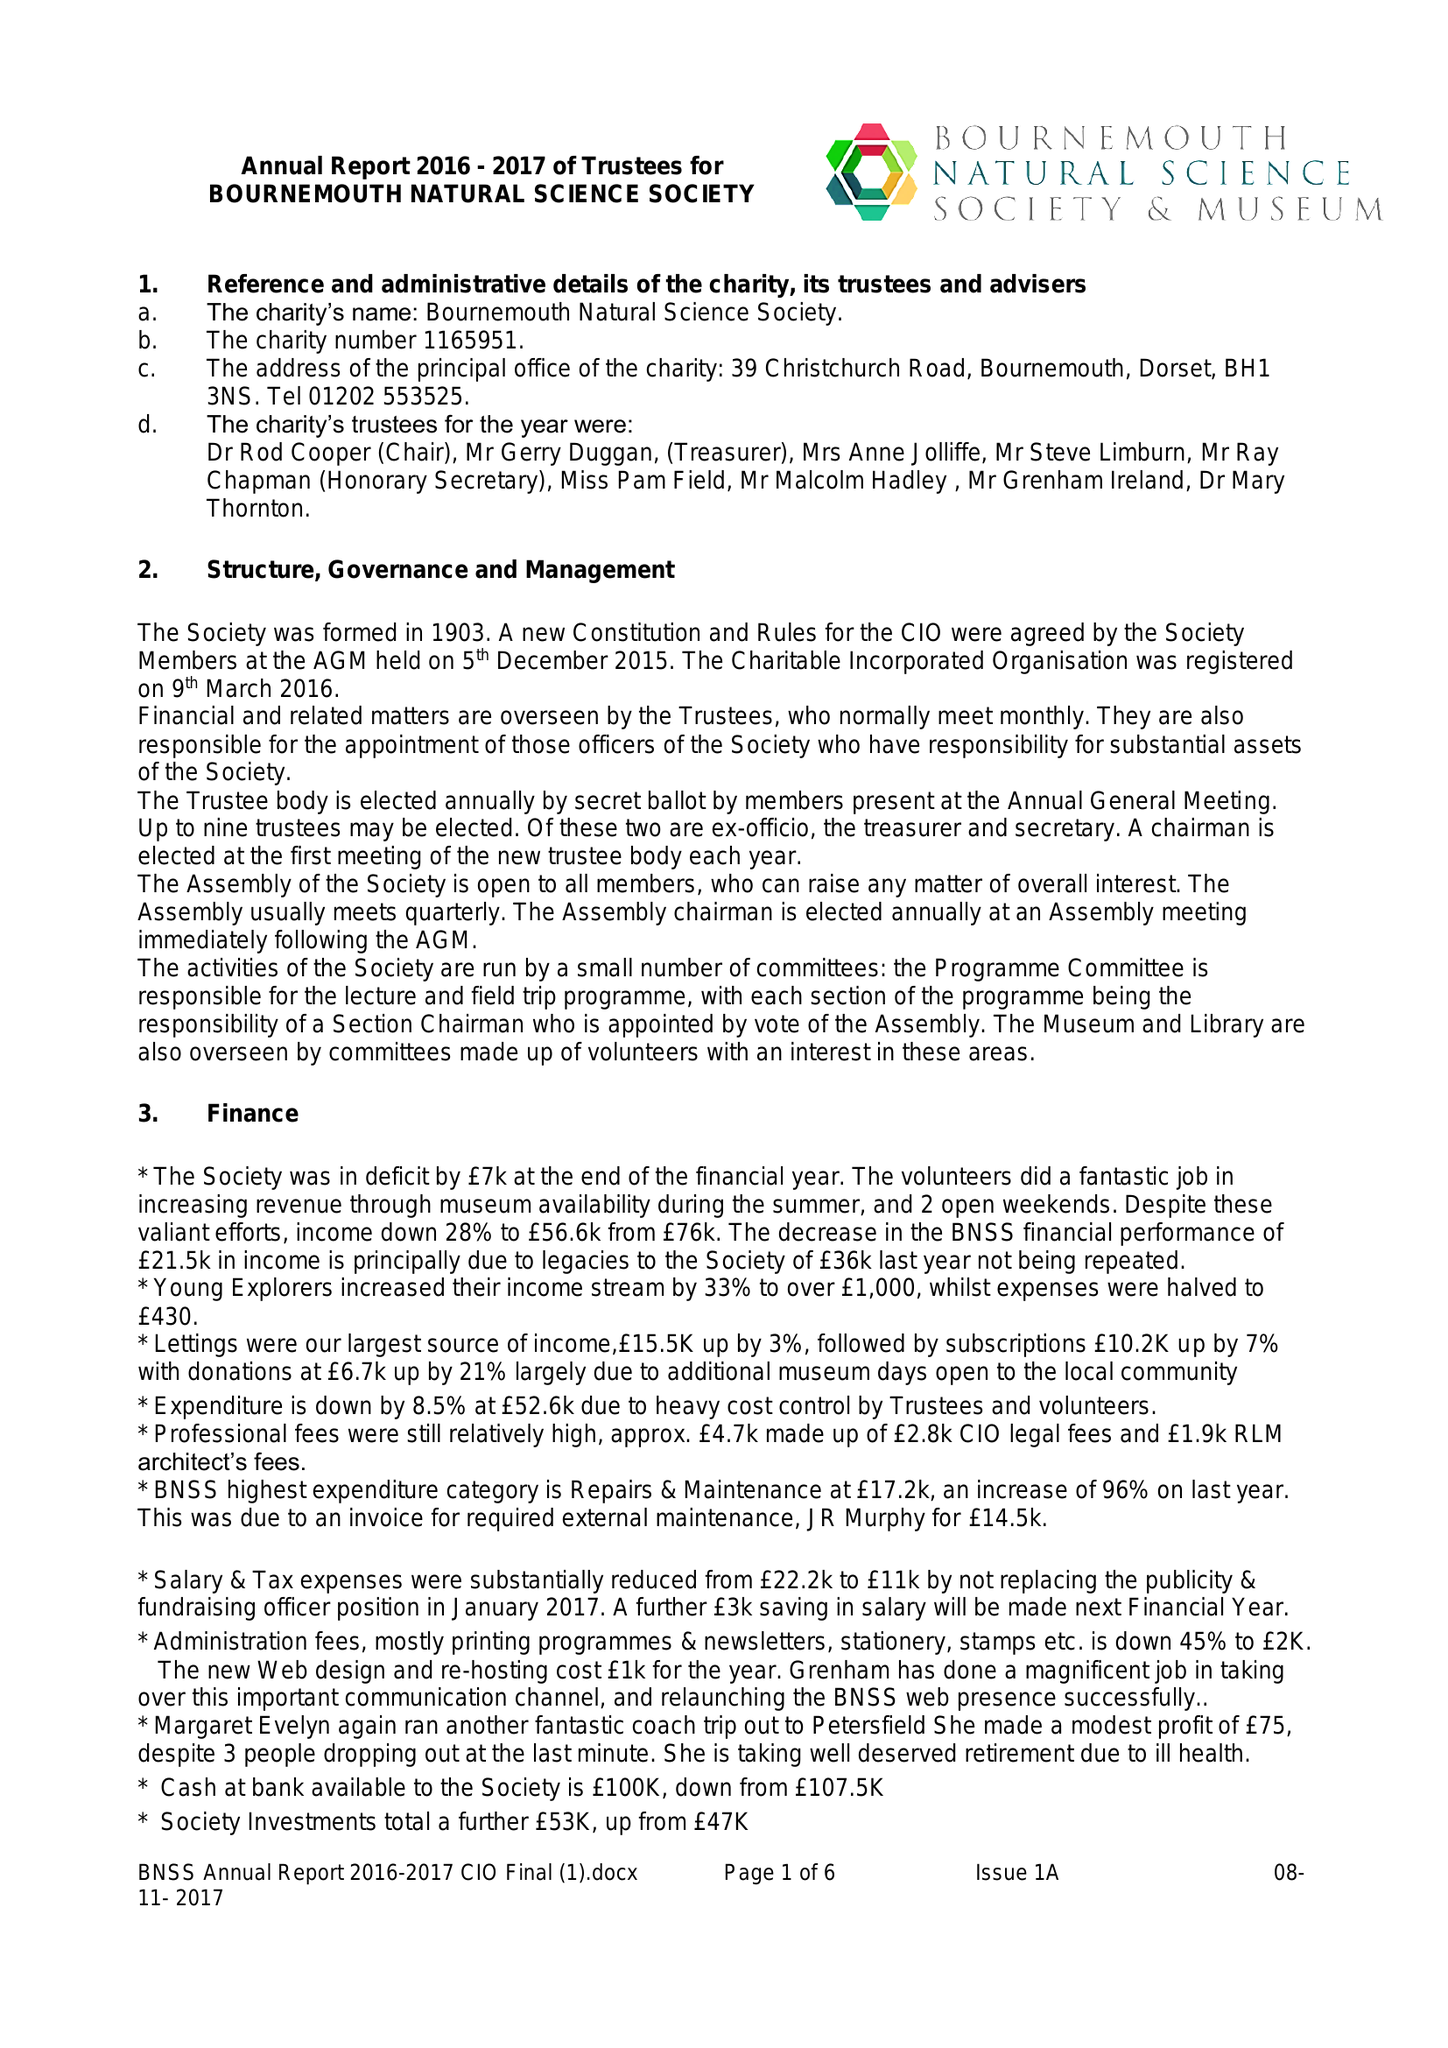What is the value for the charity_number?
Answer the question using a single word or phrase. 1165951 